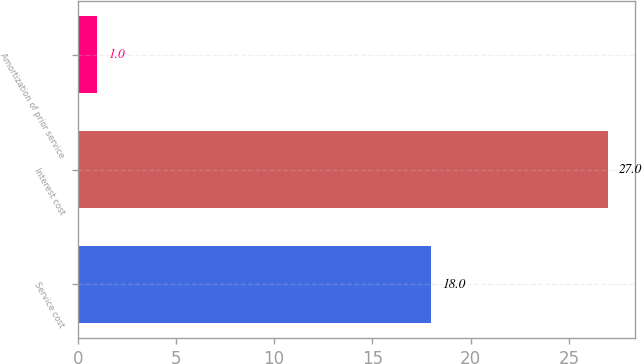Convert chart. <chart><loc_0><loc_0><loc_500><loc_500><bar_chart><fcel>Service cost<fcel>Interest cost<fcel>Amortization of prior service<nl><fcel>18<fcel>27<fcel>1<nl></chart> 